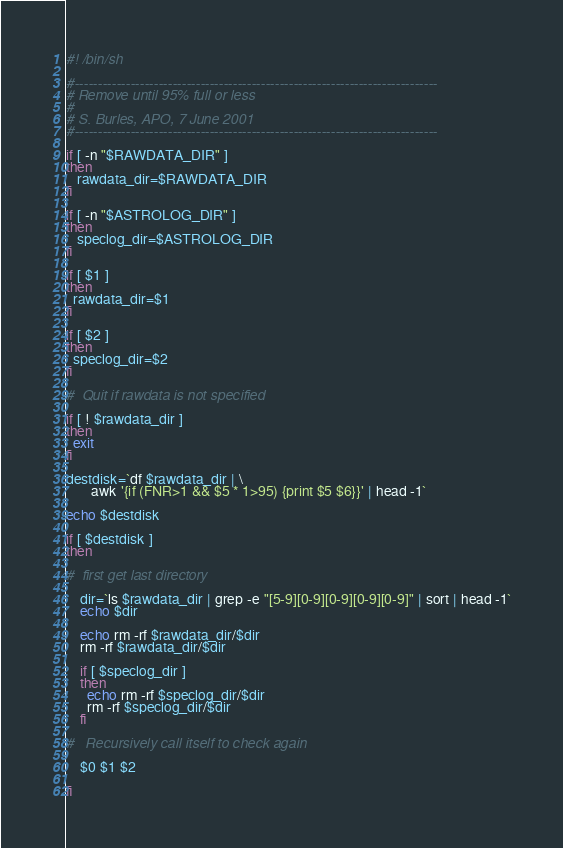<code> <loc_0><loc_0><loc_500><loc_500><_Bash_>#! /bin/sh

#------------------------------------------------------------------------------
# Remove until 95% full or less
#
# S. Burles, APO, 7 June 2001
#------------------------------------------------------------------------------

if [ -n "$RAWDATA_DIR" ]
then
   rawdata_dir=$RAWDATA_DIR
fi

if [ -n "$ASTROLOG_DIR" ]
then 
   speclog_dir=$ASTROLOG_DIR
fi

if [ $1 ]
then 
  rawdata_dir=$1
fi

if [ $2 ]
then 
  speclog_dir=$2
fi

#  Quit if rawdata is not specified

if [ ! $rawdata_dir ] 
then
  exit
fi

destdisk=`df $rawdata_dir | \
       awk '{if (FNR>1 && $5 * 1>95) {print $5 $6}}' | head -1`

echo $destdisk

if [ $destdisk ] 
then

#  first get last directory

    dir=`ls $rawdata_dir | grep -e "[5-9][0-9][0-9][0-9][0-9]" | sort | head -1`
    echo $dir
  
    echo rm -rf $rawdata_dir/$dir
    rm -rf $rawdata_dir/$dir

    if [ $speclog_dir ]
    then 
      echo rm -rf $speclog_dir/$dir
      rm -rf $speclog_dir/$dir
    fi

#   Recursively call itself to check again

    $0 $1 $2
    
fi



</code> 